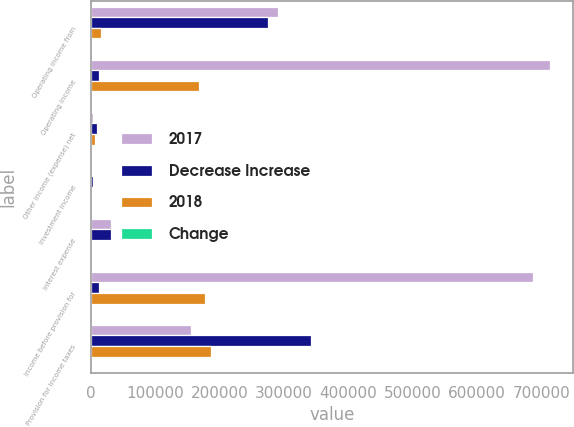<chart> <loc_0><loc_0><loc_500><loc_500><stacked_bar_chart><ecel><fcel>Operating income from<fcel>Operating income<fcel>Other income (expense) net<fcel>Investment income<fcel>Interest expense<fcel>Income before provision for<fcel>Provision for income taxes<nl><fcel>2017<fcel>291160<fcel>713523<fcel>3039<fcel>951<fcel>30884<fcel>686629<fcel>155178<nl><fcel>Decrease Increase<fcel>275305<fcel>12518.5<fcel>9182<fcel>3580<fcel>31004<fcel>12518.5<fcel>342080<nl><fcel>2018<fcel>15855<fcel>168558<fcel>6143<fcel>2629<fcel>120<fcel>177210<fcel>186902<nl><fcel>Change<fcel>5.8<fcel>19.1<fcel>66.9<fcel>73.4<fcel>0.4<fcel>20.5<fcel>54.6<nl></chart> 